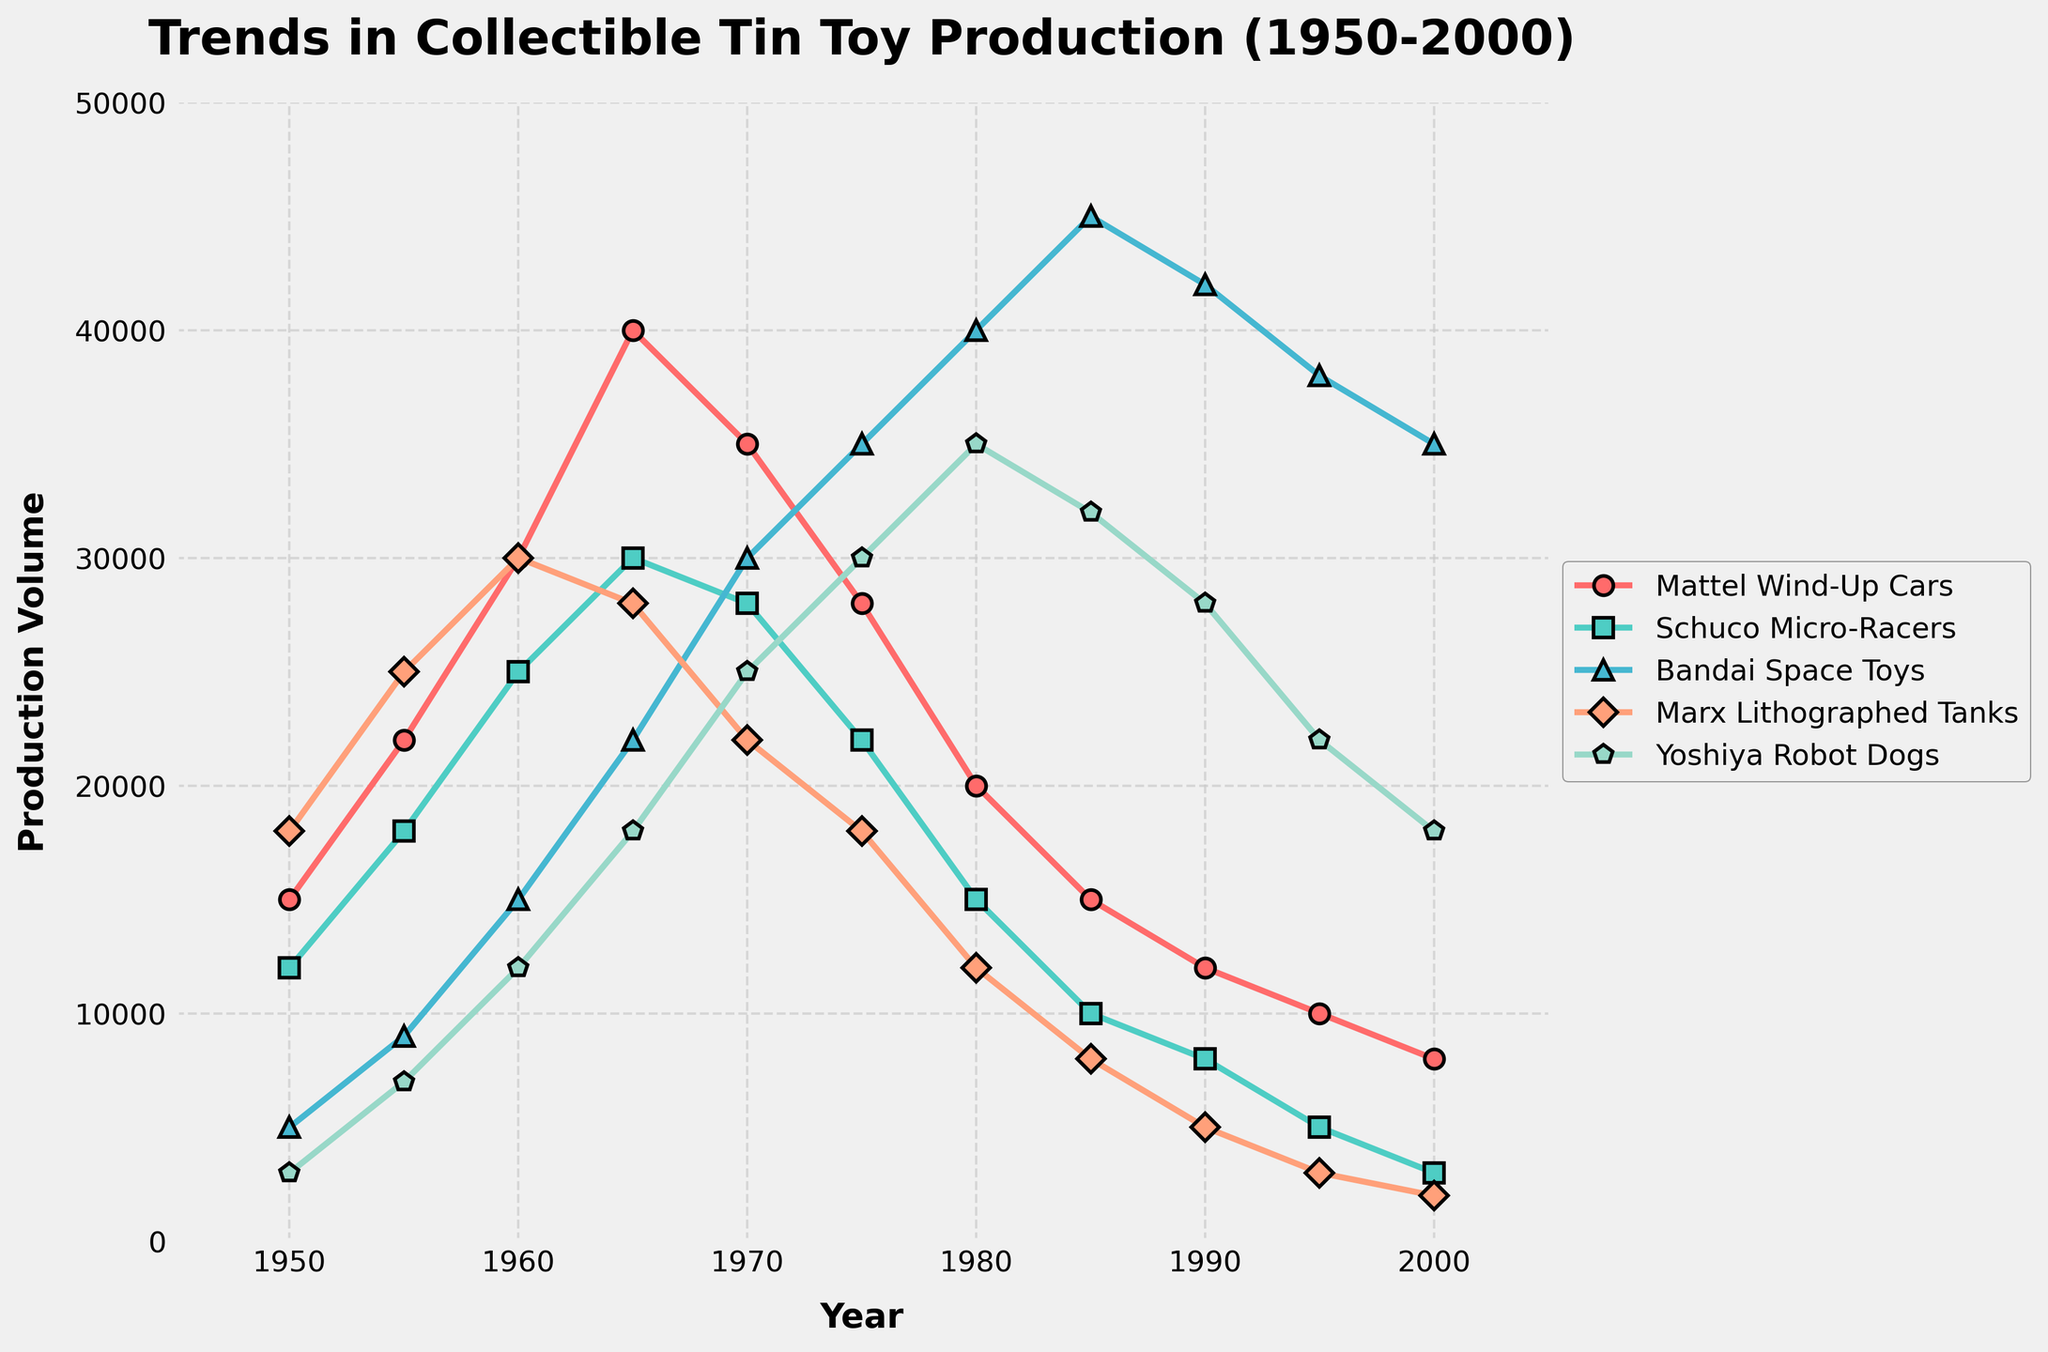What's the total production of Mattel Wind-Up Cars and Yoshiya Robot Dogs in 1960? To find the total production, add the production values of Mattel Wind-Up Cars and Yoshiya Robot Dogs in 1960. From the data, Mattel Wind-Up Cars produced 30,000 units, and Yoshiya Robot Dogs produced 12,000 units. So, 30,000 + 12,000 = 42,000.
Answer: 42,000 Which toy type had the highest production in 1985, and what was its value? Look at the production values for the year 1985. The toy types are Mattel Wind-Up Cars (15,000), Schuco Micro-Racers (10,000), Bandai Space Toys (45,000), Marx Lithographed Tanks (8,000), and Yoshiya Robot Dogs (32,000). Bandai Space Toys had the highest production with 45,000 units.
Answer: Bandai Space Toys, 45,000 What is the difference in production between the highest and lowest produced toys in 1955? First, find the highest and lowest production values in 1955. The values are Mattel Wind-Up Cars (22,000), Schuco Micro-Racers (18,000), Bandai Space Toys (9,000), Marx Lithographed Tanks (25,000), and Yoshiya Robot Dogs (7,000). The highest is Marx Lithographed Tanks (25,000), and the lowest is Yoshiya Robot Dogs (7,000). The difference is 25,000 - 7,000 = 18,000.
Answer: 18,000 In which year did Mattel Wind-Up Cars have the lowest production, and what was the value? Scan through the values of Mattel Wind-Up Cars from 1950 to 2000. The values are: 1950 (15,000), 1955 (22,000), 1960 (30,000), 1965 (40,000), 1970 (35,000), 1975 (28,000), 1980 (20,000), 1985 (15,000), 1990 (12,000), 1995 (10,000), 2000 (8,000). The lowest value is in 2000 with 8,000 units.
Answer: 2000, 8,000 What trend can be observed for Marx Lithographed Tanks from 1965 to 2000? Review the production values of Marx Lithographed Tanks for the years 1965 to 2000. The values are: 1965 (28,000), 1970 (22,000), 1975 (18,000), 1980 (12,000), 1985 (8,000), 1990 (5,000), 1995 (3,000), 2000 (2,000). The trend shows a consistent decline over the years.
Answer: Consistent decline Which toy type shows the most consistent upward trend until 1970? Look at the production values of all toy types until 1970 and identify any consistent upward trends. Mattel Wind-Up Cars: 15,000 -> 22,000 -> 30,000 -> 40,000, Schuco Micro-Racers: 12,000 -> 18,000 -> 25,000 -> 30,000, Bandai Space Toys: 5,000 -> 9,000 -> 15,000 -> 22,000, Marx Lithographed Tanks: 18,000 -> 25,000 -> 30,000 -> 28,000, Yoshiya Robot Dogs: 3,000 -> 7,000 -> 12,000 -> 18,000 -> 25,000. Yoshiya Robot Dogs shows the most consistent upward trend.
Answer: Yoshiya Robot Dogs 